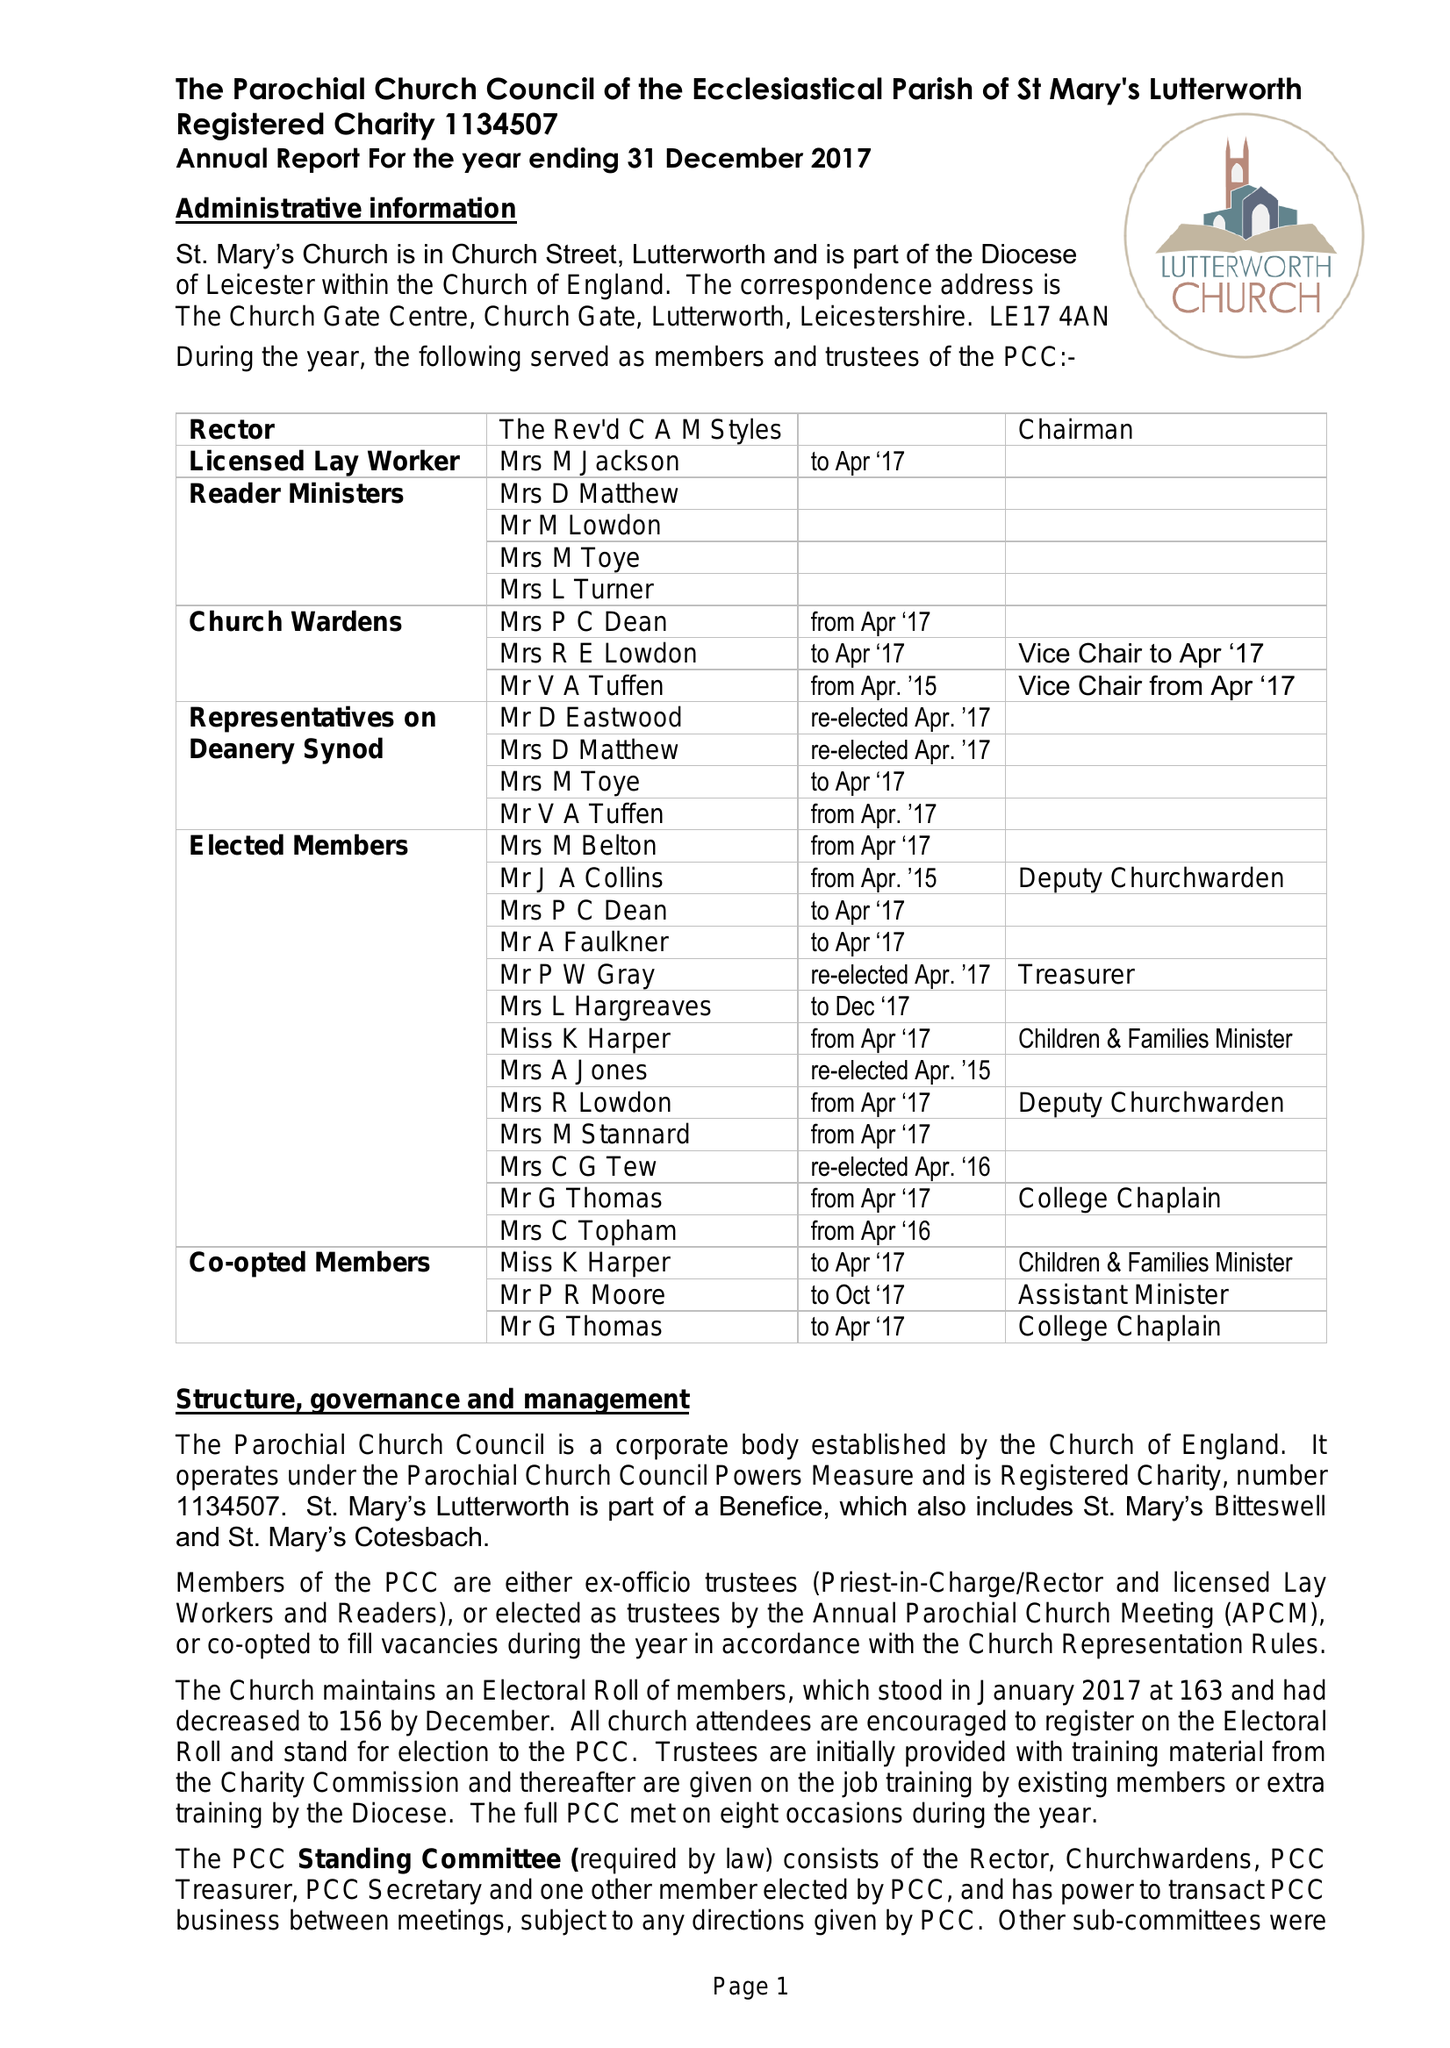What is the value for the charity_number?
Answer the question using a single word or phrase. 1134507 